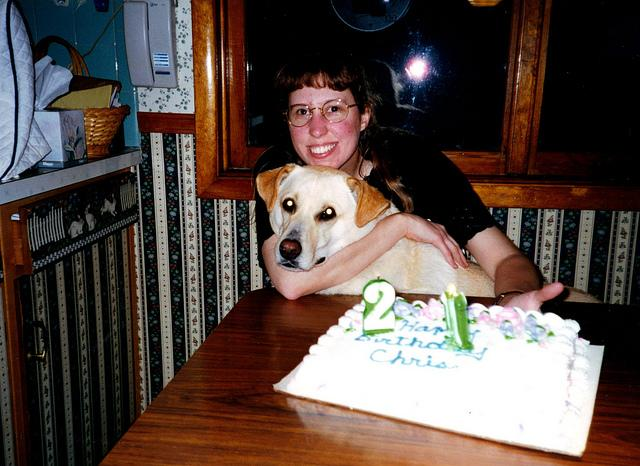Where is the dog sitting? lap 